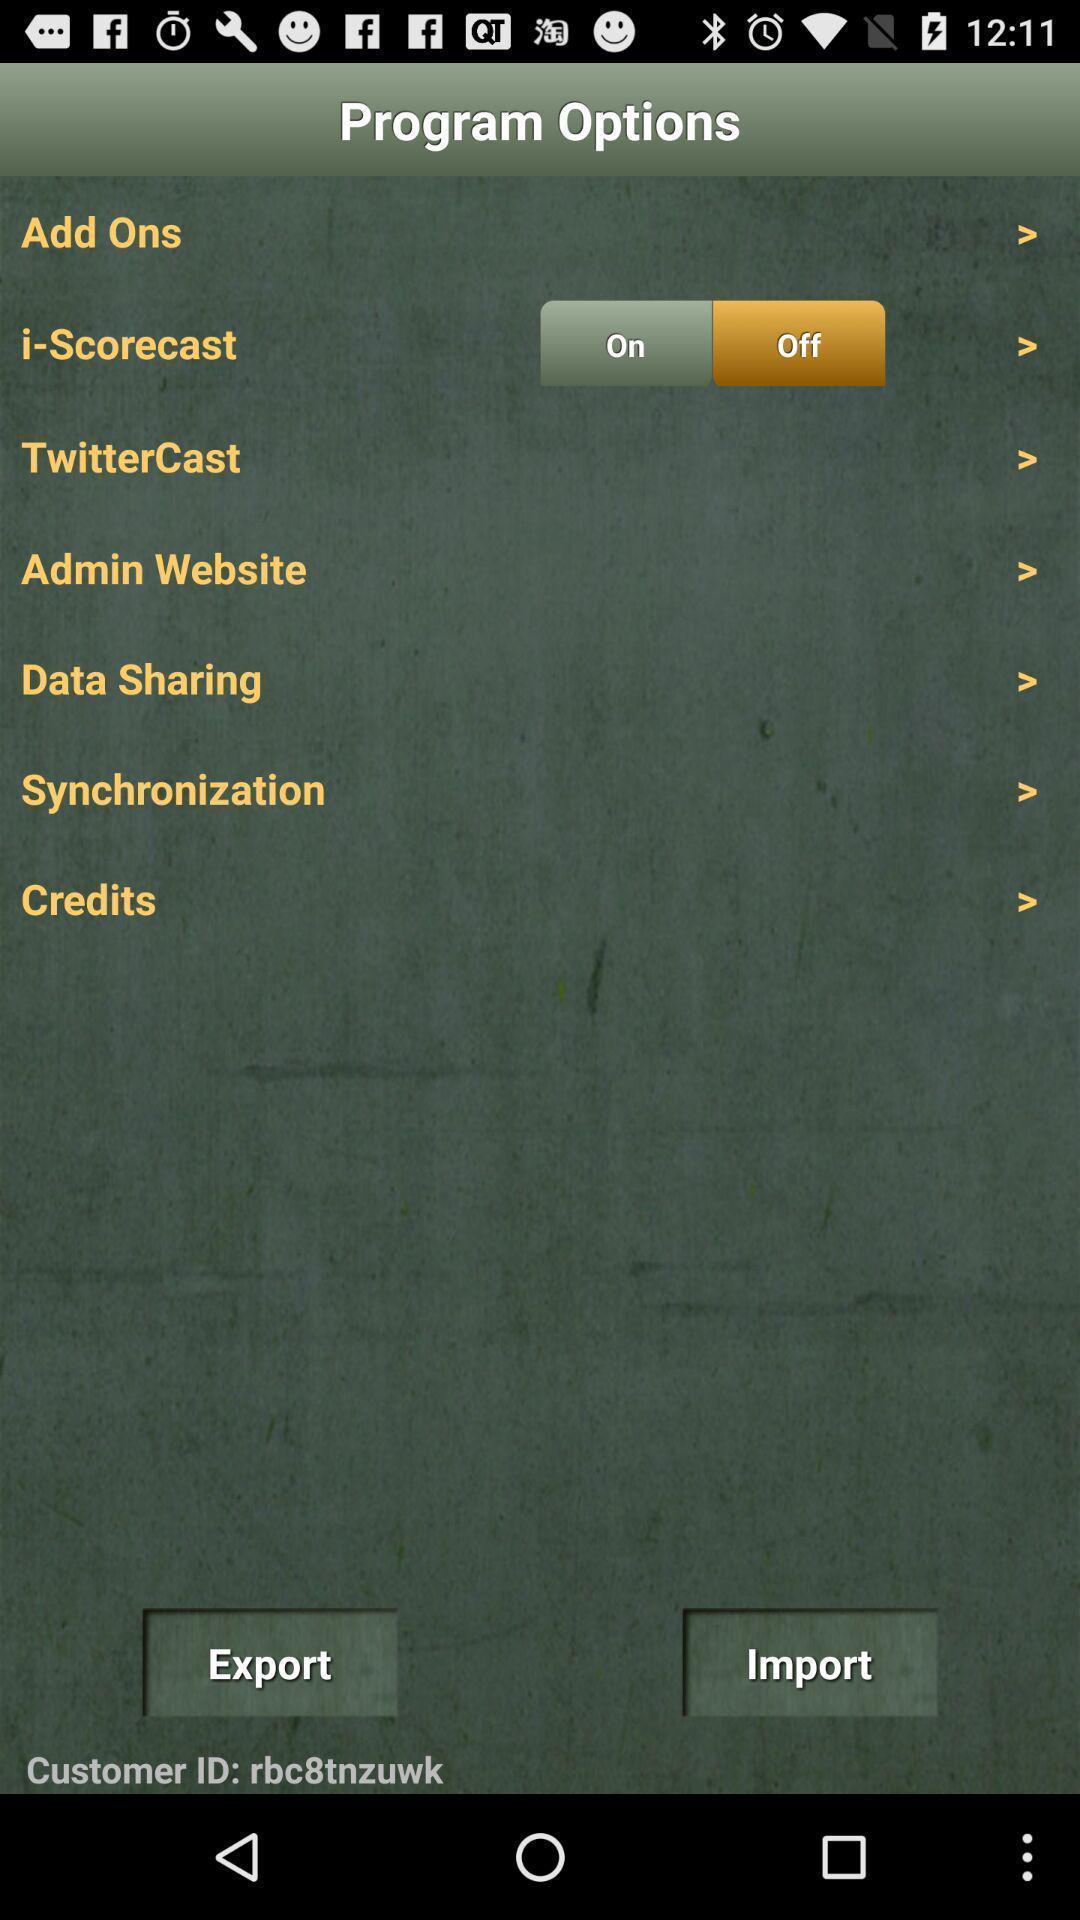What is the overall content of this screenshot? Settings page. 